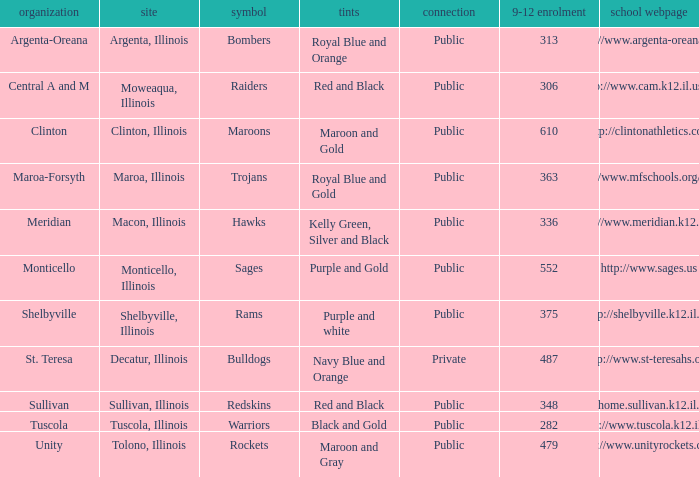What's the website of the school in Macon, Illinois? Http://www.meridian.k12.il.us/. 